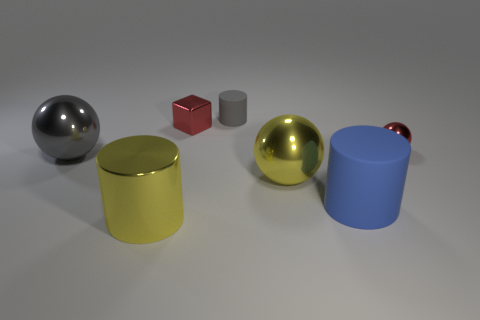Subtract all big spheres. How many spheres are left? 1 Add 2 tiny purple rubber cylinders. How many objects exist? 9 Subtract all balls. How many objects are left? 4 Add 6 metallic cubes. How many metallic cubes exist? 7 Subtract 0 purple cylinders. How many objects are left? 7 Subtract all large gray objects. Subtract all small brown shiny balls. How many objects are left? 6 Add 5 small shiny things. How many small shiny things are left? 7 